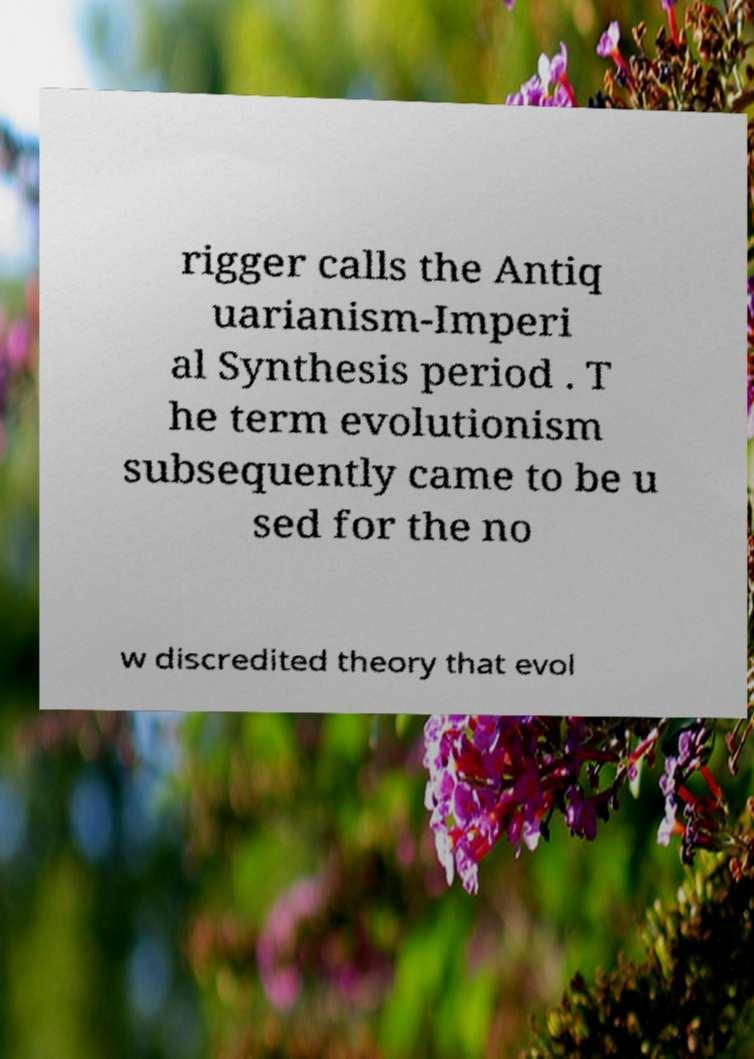Please read and relay the text visible in this image. What does it say? rigger calls the Antiq uarianism-Imperi al Synthesis period . T he term evolutionism subsequently came to be u sed for the no w discredited theory that evol 